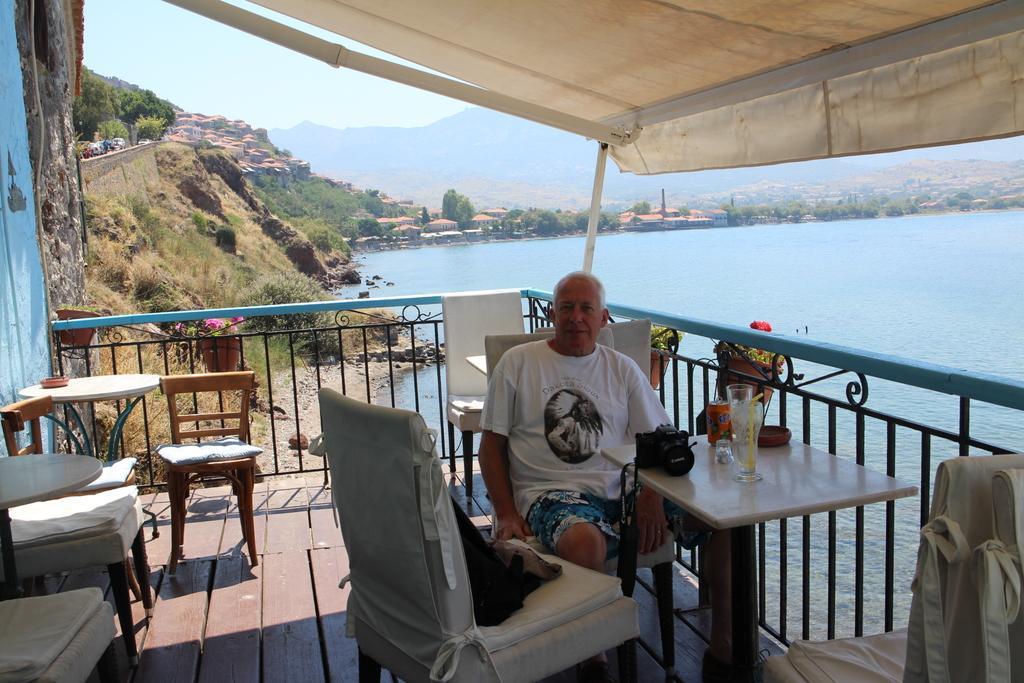Describe this image in one or two sentences. In this picture I can observe a man sitting in the chair in front of a table on which there is a glass placed. I can observe railing which is in blue and black color. On the right side there is a river. In the background there are trees, hills and a sky. 